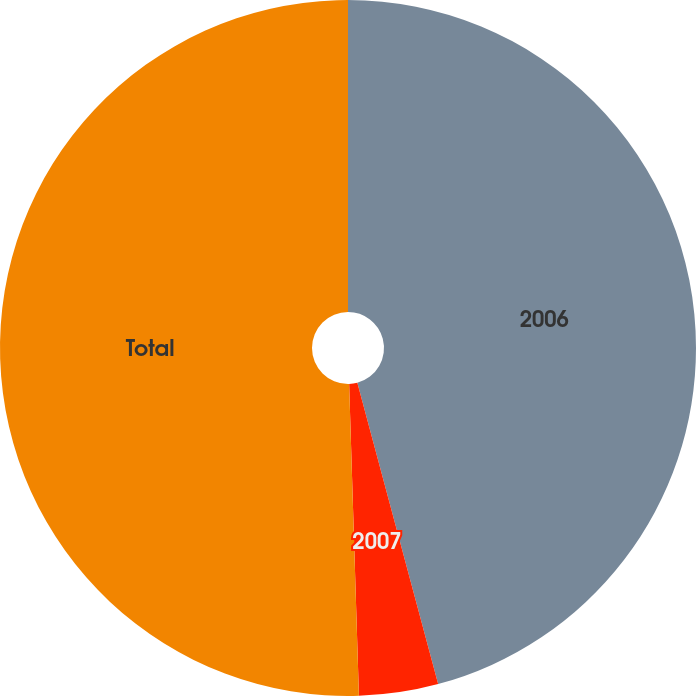<chart> <loc_0><loc_0><loc_500><loc_500><pie_chart><fcel>2006<fcel>2007<fcel>Total<nl><fcel>45.83%<fcel>3.67%<fcel>50.5%<nl></chart> 